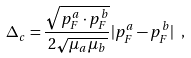<formula> <loc_0><loc_0><loc_500><loc_500>\Delta _ { c } = \frac { \sqrt { p _ { F } ^ { a } \cdot p _ { F } ^ { b } } } { 2 \sqrt { \mu _ { a } \mu _ { b } } } | p _ { F } ^ { a } - p _ { F } ^ { b } | \ ,</formula> 